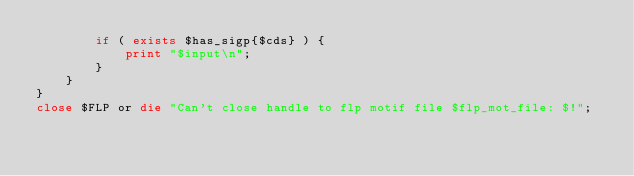Convert code to text. <code><loc_0><loc_0><loc_500><loc_500><_Perl_>        if ( exists $has_sigp{$cds} ) { 
            print "$input\n";
        }
    }
}
close $FLP or die "Can't close handle to flp motif file $flp_mot_file: $!";

</code> 